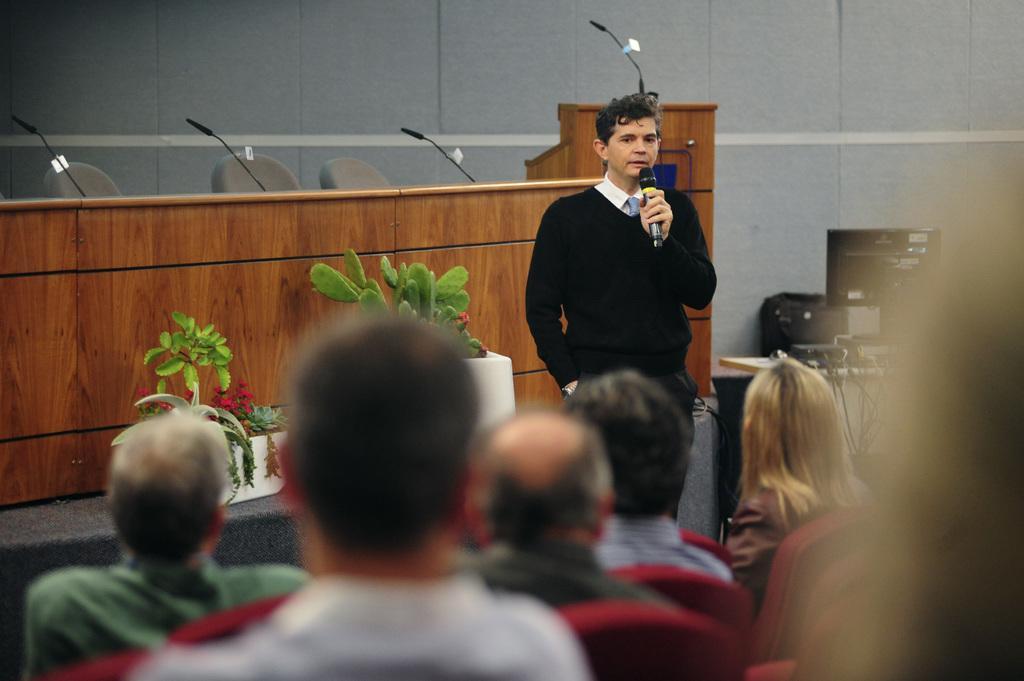Please provide a concise description of this image. In this image I can see a person standing. In the background there is a wooden table. Behind the person there are few plants. At the bottom I can see some people. 